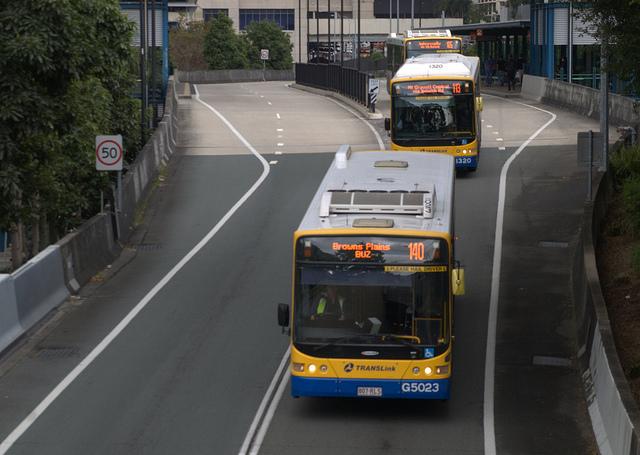What number is showing on the bus?
Concise answer only. 140. Are these buses in a race?
Answer briefly. No. In which direction are the buses going?
Short answer required. South. 